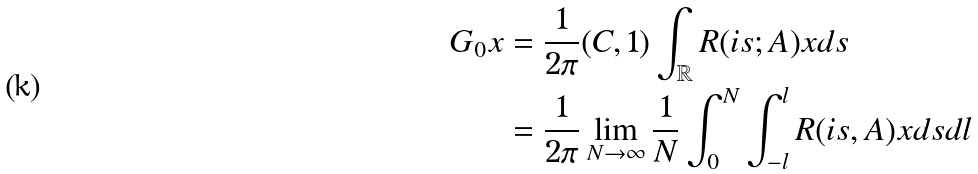<formula> <loc_0><loc_0><loc_500><loc_500>G _ { 0 } x & = \frac { 1 } { 2 \pi } ( C , 1 ) \int _ { \mathbb { R } } R ( i s ; A ) x d s \\ & = \frac { 1 } { 2 \pi } \lim _ { N \to \infty } \frac { 1 } { N } \int ^ { N } _ { 0 } \int ^ { l } _ { - l } R ( i s , A ) x d s d l</formula> 